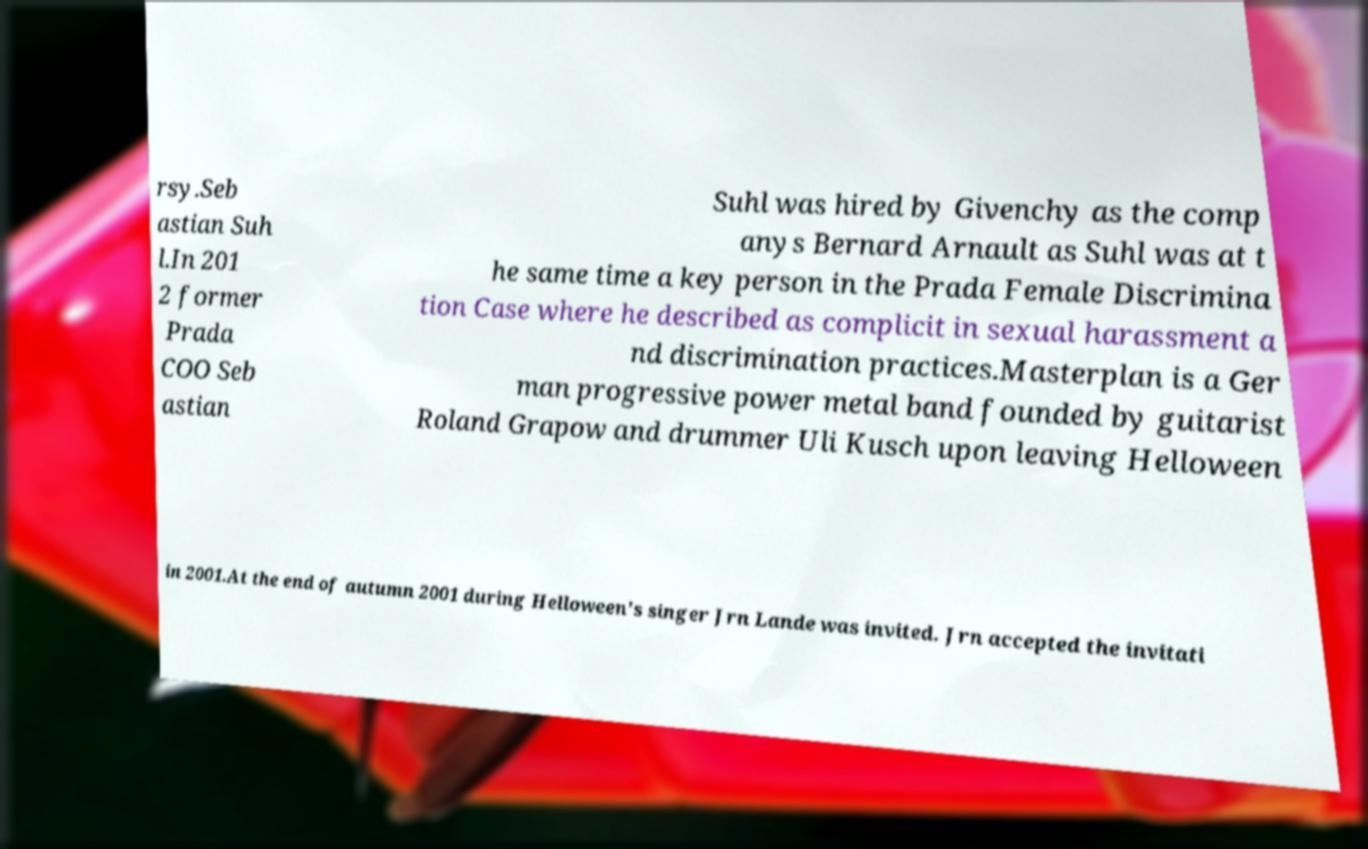What messages or text are displayed in this image? I need them in a readable, typed format. rsy.Seb astian Suh l.In 201 2 former Prada COO Seb astian Suhl was hired by Givenchy as the comp anys Bernard Arnault as Suhl was at t he same time a key person in the Prada Female Discrimina tion Case where he described as complicit in sexual harassment a nd discrimination practices.Masterplan is a Ger man progressive power metal band founded by guitarist Roland Grapow and drummer Uli Kusch upon leaving Helloween in 2001.At the end of autumn 2001 during Helloween's singer Jrn Lande was invited. Jrn accepted the invitati 